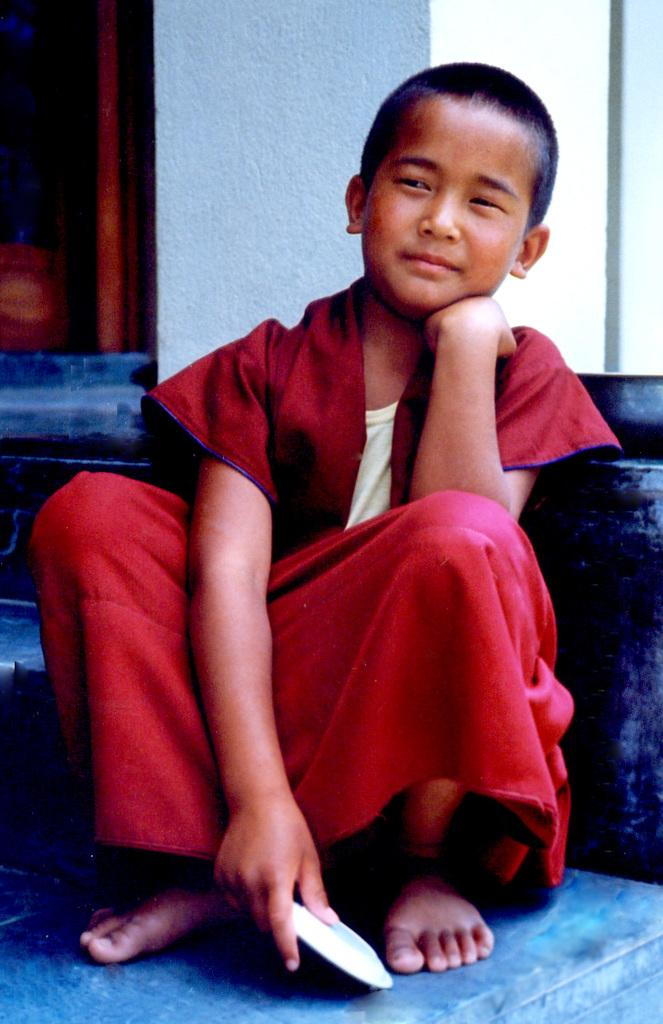What is the main subject of the image? The main subject of the image is a boy. Where is the boy located in the image? The boy is sitting in the middle of the image. What is the boy holding in his hand? The boy is holding something in his hand. What can be seen behind the boy? There is a wall visible behind the boy. What is the name of the fan in the image? There is no fan present in the image. What type of meeting is taking place in the image? There is no meeting depicted in the image; it features a boy sitting and holding something in his hand. 